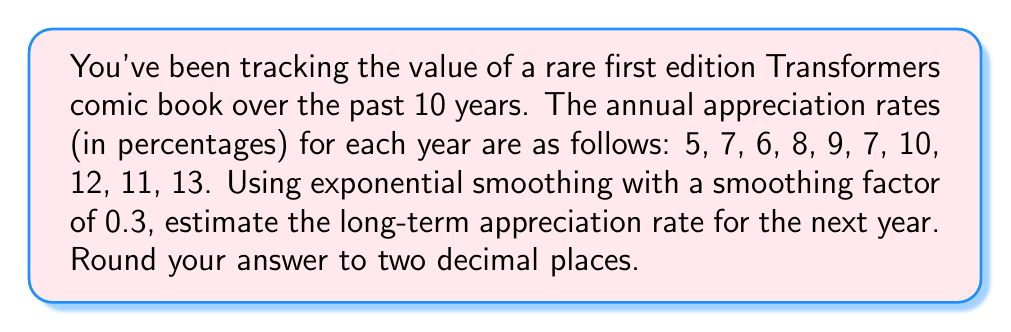Provide a solution to this math problem. To solve this problem, we'll use exponential smoothing, which is a time series forecasting method that gives more weight to recent observations. The formula for exponential smoothing is:

$$S_t = \alpha Y_t + (1-\alpha)S_{t-1}$$

Where:
$S_t$ is the smoothed value at time t
$\alpha$ is the smoothing factor (0.3 in this case)
$Y_t$ is the observed value at time t
$S_{t-1}$ is the previous smoothed value

Let's calculate the smoothed values:

1. $S_1 = Y_1 = 5$ (initial value)
2. $S_2 = 0.3(7) + 0.7(5) = 5.6$
3. $S_3 = 0.3(6) + 0.7(5.6) = 5.72$
4. $S_4 = 0.3(8) + 0.7(5.72) = 6.404$
5. $S_5 = 0.3(9) + 0.7(6.404) = 7.1828$
6. $S_6 = 0.3(7) + 0.7(7.1828) = 7.12796$
7. $S_7 = 0.3(10) + 0.7(7.12796) = 7.989572$
8. $S_8 = 0.3(12) + 0.7(7.989572) = 9.1927004$
9. $S_9 = 0.3(11) + 0.7(9.1927004) = 9.7348903$
10. $S_{10} = 0.3(13) + 0.7(9.7348903) = 10.71442321$

The final smoothed value, $S_{10} = 10.71442321$, represents our estimate for the long-term appreciation rate for the next year.
Answer: 10.71% 